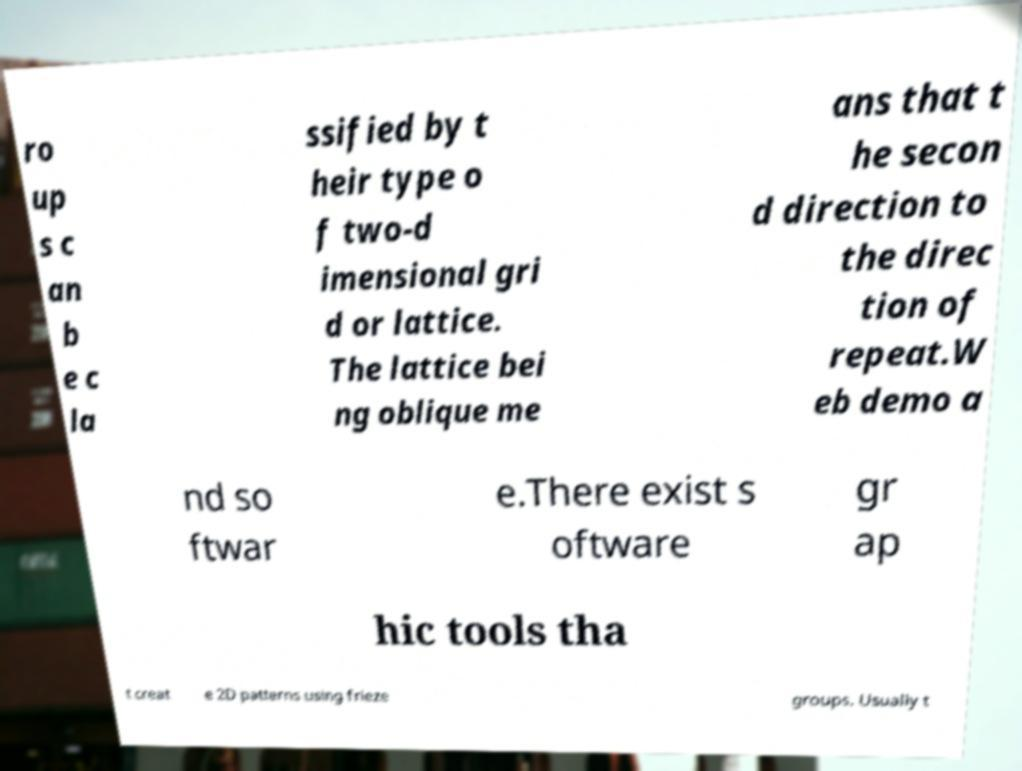Can you accurately transcribe the text from the provided image for me? ro up s c an b e c la ssified by t heir type o f two-d imensional gri d or lattice. The lattice bei ng oblique me ans that t he secon d direction to the direc tion of repeat.W eb demo a nd so ftwar e.There exist s oftware gr ap hic tools tha t creat e 2D patterns using frieze groups. Usually t 